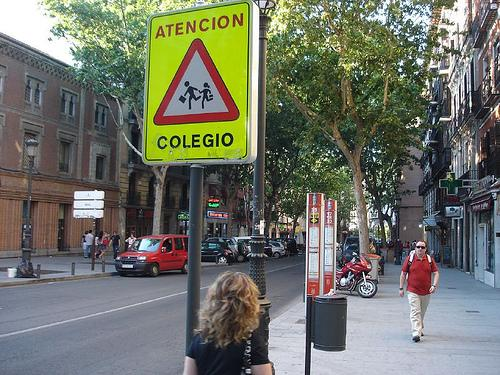Describe any unique or unusual features of the scene. One distinct feature is the neon green sign with a red triangle, which stands out from the typical urban environment. What color is the sign and what's the shape on it? The sign is neon green with a red triangle on it. Evaluate the quality of the image based on its objects and their positions. The quality of the image is good, with objects placed naturally in the scene, portraying a vivid representation of a city street. Count the number of garbage cans in the image and describe their appearance. There are two garbage cans in the image - one gray and one black. Please give a brief summary of this picture, mentioning the major elements. The picture shows a daytime city scene with several people walking on the sidewalk, cars parked on the street, a red motorcycle, and various street signs and objects, like a green street sign, red triangle sign, and garbage cans. Deduce a complex reasoning task from the image. Based on the people's clothing and the presence of parked cars and motorcycles, determine the possible time of the day, season, and whether it's a weekday or weekend. How many vehicles can be seen in this image? There are at least five vehicles visible in the image: a red car, a red van, a red motorcycle, and at least two more parked cars. What emotions do you think this image might evoke in a viewer? The image might evoke a feeling of liveliness, urban life, and daily activities in a viewer. What is the overall sentiment or tone of the image? The overall sentiment of the image is active and vibrant, showcasing everyday urban life. Analyze the interaction between the objects in the image and explain what's happening. People are walking along the sidewalk, interacting with each other, and passing by parked vehicles, street signs, and trash cans. It depicts daily life on the streets of a city. What is the man wearing a red shirt doing in the image? He is standing, possibly observing or waiting. Is there a blue car parked on the street? There is a red car parked on the street but not a blue car, so this instruction would be misleading. Which objects appear to be interacting with each other in the image? People walking, vehicles parked, trees, and buildings form a typical street scene. How many distinct captions mention a man on the sidewalk? 7 distinct captions. Locate the street lights in the image. X:15 Y:126 Width:32 Height:32 Assess the quality of the image considering objects' details. Image quality appears to be good, with objects clearly visible. What are the colors of the trash cans present in the image? Gray trashcan and black garbage can. What types of trees can be seen in the row of green trees? Not enough information provided in the image captions. Create a short description of the image. A daytime downtown scene with people walking on sidewalks, various vehicles parked, trees, and a street sign. Are there any motorcycles in the image? If so, provide their details. Yes, red motorcycle parked on side walk. Describe the warning sign in the picture. A green and red warning sign with a red triangle. Are there orange trees in a row? There is a row of green trees, but not orange ones, making this instruction confusing. What type of building is located at the coordinates X:413 Y:0? Apartment building. Is there anything unusual or unexpected in the image? No, everything appears normal for an urban scene. Is there a white garbage can on the sidewalk? There is a black garbage can on the sidewalk, but not a white one, so this instruction is misleading. What sentiment does this daytime scene convey? A calm, peaceful atmosphere. List the color, model, and location of vehicles in the scene. Red bike near sidewalk, red car parked on street, red van parked at side of road. Identify how many captions refer to a woman in black shirt. 1 caption. Identify the people and what they are doing in the image. Man walking on side walk, lady walking on side walk, man in red shirt and khakis. Can you find a woman wearing a yellow shirt? There is a lady wearing a black shirt, but not a yellow one, making this instruction misleading. What is happening at the coordinates X:382 Y:225? A person walking down the street. What does the neon green sign contain, apart from its color? A red triangle and possibly some text. In a multiple choice question, which vehicle is parked on the sidewalk: A) Red car B) Red motorcycle C) Red van D) Grey car B) Red motorcycle Is there a yellow motorcycle parked on the sidewalk? There is a red motorcycle parked on the sidewalk, but not a yellow one, making this instruction misleading. Can you see a purple street light? There is a street light, but it is not specified as purple, so this instruction would be misleading. 